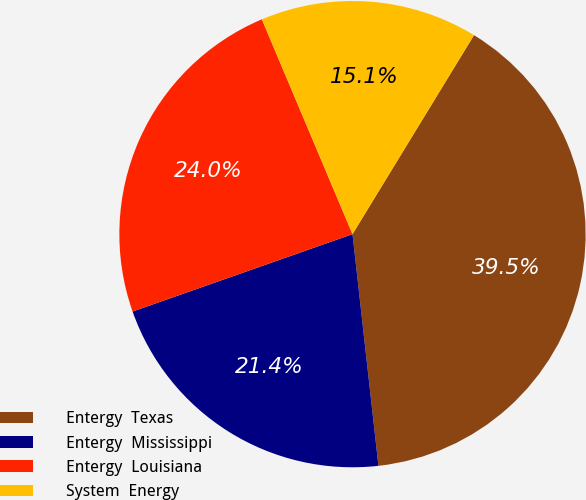<chart> <loc_0><loc_0><loc_500><loc_500><pie_chart><fcel>Entergy  Texas<fcel>Entergy  Mississippi<fcel>Entergy  Louisiana<fcel>System  Energy<nl><fcel>39.5%<fcel>21.39%<fcel>24.03%<fcel>15.08%<nl></chart> 